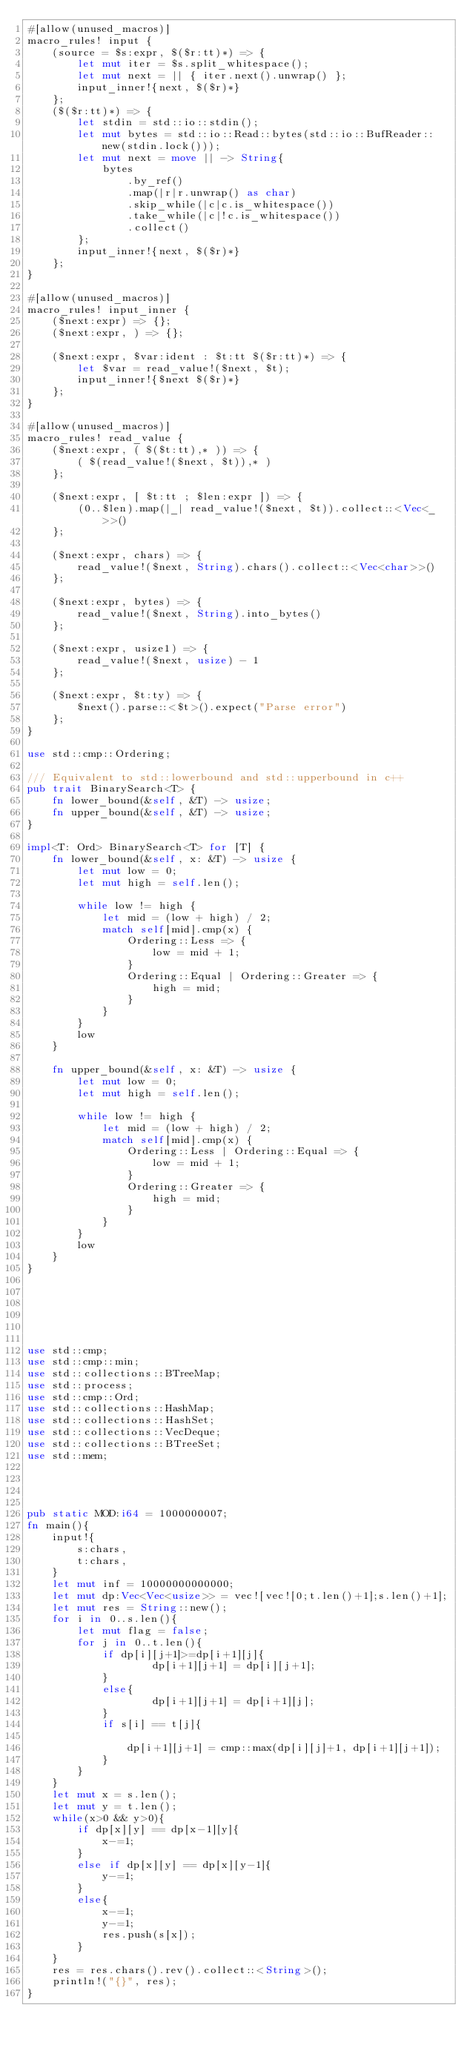<code> <loc_0><loc_0><loc_500><loc_500><_Rust_>#[allow(unused_macros)]
macro_rules! input {
    (source = $s:expr, $($r:tt)*) => {
        let mut iter = $s.split_whitespace();
        let mut next = || { iter.next().unwrap() };
        input_inner!{next, $($r)*}
    };
    ($($r:tt)*) => {
        let stdin = std::io::stdin();
        let mut bytes = std::io::Read::bytes(std::io::BufReader::new(stdin.lock()));
        let mut next = move || -> String{
            bytes
                .by_ref()
                .map(|r|r.unwrap() as char)
                .skip_while(|c|c.is_whitespace())
                .take_while(|c|!c.is_whitespace())
                .collect()
        };
        input_inner!{next, $($r)*}
    };
}
 
#[allow(unused_macros)]
macro_rules! input_inner {
    ($next:expr) => {};
    ($next:expr, ) => {};
 
    ($next:expr, $var:ident : $t:tt $($r:tt)*) => {
        let $var = read_value!($next, $t);
        input_inner!{$next $($r)*}
    };
}
 
#[allow(unused_macros)]
macro_rules! read_value {
    ($next:expr, ( $($t:tt),* )) => {
        ( $(read_value!($next, $t)),* )
    };
 
    ($next:expr, [ $t:tt ; $len:expr ]) => {
        (0..$len).map(|_| read_value!($next, $t)).collect::<Vec<_>>()
    };
 
    ($next:expr, chars) => {
        read_value!($next, String).chars().collect::<Vec<char>>()
    };
 
    ($next:expr, bytes) => {
        read_value!($next, String).into_bytes()
    };
 
    ($next:expr, usize1) => {
        read_value!($next, usize) - 1
    };
 
    ($next:expr, $t:ty) => {
        $next().parse::<$t>().expect("Parse error")
    };
}
 
use std::cmp::Ordering;
 
/// Equivalent to std::lowerbound and std::upperbound in c++
pub trait BinarySearch<T> {
    fn lower_bound(&self, &T) -> usize;
    fn upper_bound(&self, &T) -> usize;
}
 
impl<T: Ord> BinarySearch<T> for [T] {
    fn lower_bound(&self, x: &T) -> usize {
        let mut low = 0;
        let mut high = self.len();
 
        while low != high {
            let mid = (low + high) / 2;
            match self[mid].cmp(x) {
                Ordering::Less => {
                    low = mid + 1;
                }
                Ordering::Equal | Ordering::Greater => {
                    high = mid;
                }
            }
        }
        low
    }
 
    fn upper_bound(&self, x: &T) -> usize {
        let mut low = 0;
        let mut high = self.len();
 
        while low != high {
            let mid = (low + high) / 2;
            match self[mid].cmp(x) {
                Ordering::Less | Ordering::Equal => {
                    low = mid + 1;
                }
                Ordering::Greater => {
                    high = mid;
                }
            }
        }
        low
    }
}
 
 
 
 
 
 
use std::cmp;
use std::cmp::min;
use std::collections::BTreeMap;
use std::process;
use std::cmp::Ord;
use std::collections::HashMap;
use std::collections::HashSet;
use std::collections::VecDeque;
use std::collections::BTreeSet;
use std::mem;



 
pub static MOD:i64 = 1000000007;
fn main(){
    input!{
        s:chars,
        t:chars,
    }
    let mut inf = 10000000000000;
    let mut dp:Vec<Vec<usize>> = vec![vec![0;t.len()+1];s.len()+1];
    let mut res = String::new();
    for i in 0..s.len(){
        let mut flag = false;
        for j in 0..t.len(){
            if dp[i][j+1]>=dp[i+1][j]{
                    dp[i+1][j+1] = dp[i][j+1];
            }
            else{
                    dp[i+1][j+1] = dp[i+1][j];
            }
            if s[i] == t[j]{

                dp[i+1][j+1] = cmp::max(dp[i][j]+1, dp[i+1][j+1]);
            }
        }
    }
    let mut x = s.len();
    let mut y = t.len();
    while(x>0 && y>0){
        if dp[x][y] == dp[x-1][y]{
            x-=1;
        }
        else if dp[x][y] == dp[x][y-1]{
            y-=1;
        }
        else{
            x-=1;
            y-=1;
            res.push(s[x]);
        }
    }
    res = res.chars().rev().collect::<String>();
    println!("{}", res);
}

</code> 